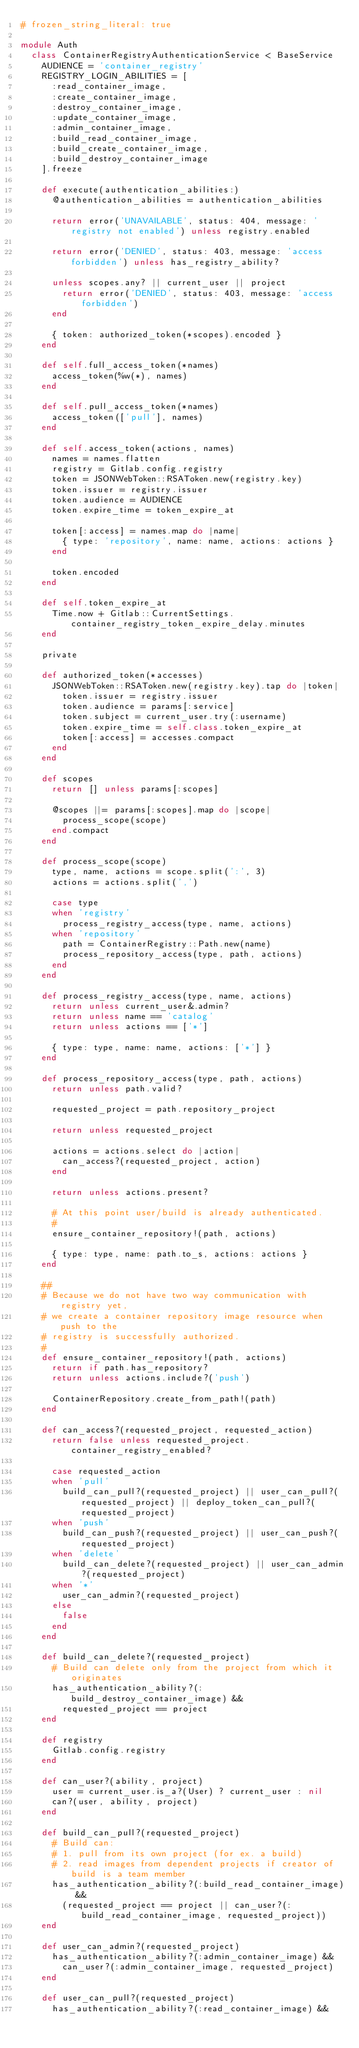<code> <loc_0><loc_0><loc_500><loc_500><_Ruby_># frozen_string_literal: true

module Auth
  class ContainerRegistryAuthenticationService < BaseService
    AUDIENCE = 'container_registry'
    REGISTRY_LOGIN_ABILITIES = [
      :read_container_image,
      :create_container_image,
      :destroy_container_image,
      :update_container_image,
      :admin_container_image,
      :build_read_container_image,
      :build_create_container_image,
      :build_destroy_container_image
    ].freeze

    def execute(authentication_abilities:)
      @authentication_abilities = authentication_abilities

      return error('UNAVAILABLE', status: 404, message: 'registry not enabled') unless registry.enabled

      return error('DENIED', status: 403, message: 'access forbidden') unless has_registry_ability?

      unless scopes.any? || current_user || project
        return error('DENIED', status: 403, message: 'access forbidden')
      end

      { token: authorized_token(*scopes).encoded }
    end

    def self.full_access_token(*names)
      access_token(%w(*), names)
    end

    def self.pull_access_token(*names)
      access_token(['pull'], names)
    end

    def self.access_token(actions, names)
      names = names.flatten
      registry = Gitlab.config.registry
      token = JSONWebToken::RSAToken.new(registry.key)
      token.issuer = registry.issuer
      token.audience = AUDIENCE
      token.expire_time = token_expire_at

      token[:access] = names.map do |name|
        { type: 'repository', name: name, actions: actions }
      end

      token.encoded
    end

    def self.token_expire_at
      Time.now + Gitlab::CurrentSettings.container_registry_token_expire_delay.minutes
    end

    private

    def authorized_token(*accesses)
      JSONWebToken::RSAToken.new(registry.key).tap do |token|
        token.issuer = registry.issuer
        token.audience = params[:service]
        token.subject = current_user.try(:username)
        token.expire_time = self.class.token_expire_at
        token[:access] = accesses.compact
      end
    end

    def scopes
      return [] unless params[:scopes]

      @scopes ||= params[:scopes].map do |scope|
        process_scope(scope)
      end.compact
    end

    def process_scope(scope)
      type, name, actions = scope.split(':', 3)
      actions = actions.split(',')

      case type
      when 'registry'
        process_registry_access(type, name, actions)
      when 'repository'
        path = ContainerRegistry::Path.new(name)
        process_repository_access(type, path, actions)
      end
    end

    def process_registry_access(type, name, actions)
      return unless current_user&.admin?
      return unless name == 'catalog'
      return unless actions == ['*']

      { type: type, name: name, actions: ['*'] }
    end

    def process_repository_access(type, path, actions)
      return unless path.valid?

      requested_project = path.repository_project

      return unless requested_project

      actions = actions.select do |action|
        can_access?(requested_project, action)
      end

      return unless actions.present?

      # At this point user/build is already authenticated.
      #
      ensure_container_repository!(path, actions)

      { type: type, name: path.to_s, actions: actions }
    end

    ##
    # Because we do not have two way communication with registry yet,
    # we create a container repository image resource when push to the
    # registry is successfully authorized.
    #
    def ensure_container_repository!(path, actions)
      return if path.has_repository?
      return unless actions.include?('push')

      ContainerRepository.create_from_path!(path)
    end

    def can_access?(requested_project, requested_action)
      return false unless requested_project.container_registry_enabled?

      case requested_action
      when 'pull'
        build_can_pull?(requested_project) || user_can_pull?(requested_project) || deploy_token_can_pull?(requested_project)
      when 'push'
        build_can_push?(requested_project) || user_can_push?(requested_project)
      when 'delete'
        build_can_delete?(requested_project) || user_can_admin?(requested_project)
      when '*'
        user_can_admin?(requested_project)
      else
        false
      end
    end

    def build_can_delete?(requested_project)
      # Build can delete only from the project from which it originates
      has_authentication_ability?(:build_destroy_container_image) &&
        requested_project == project
    end

    def registry
      Gitlab.config.registry
    end

    def can_user?(ability, project)
      user = current_user.is_a?(User) ? current_user : nil
      can?(user, ability, project)
    end

    def build_can_pull?(requested_project)
      # Build can:
      # 1. pull from its own project (for ex. a build)
      # 2. read images from dependent projects if creator of build is a team member
      has_authentication_ability?(:build_read_container_image) &&
        (requested_project == project || can_user?(:build_read_container_image, requested_project))
    end

    def user_can_admin?(requested_project)
      has_authentication_ability?(:admin_container_image) &&
        can_user?(:admin_container_image, requested_project)
    end

    def user_can_pull?(requested_project)
      has_authentication_ability?(:read_container_image) &&</code> 